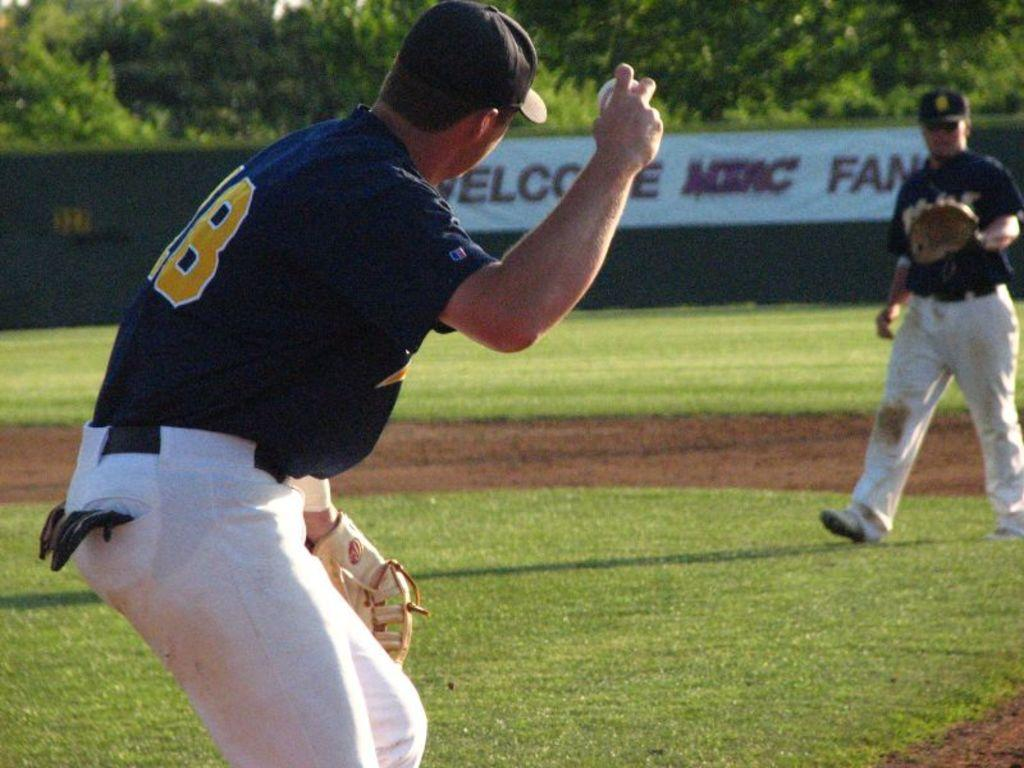<image>
Create a compact narrative representing the image presented. Two baseball players are playing catch in front of a sign that says, Welcome MIAC Fans'. 